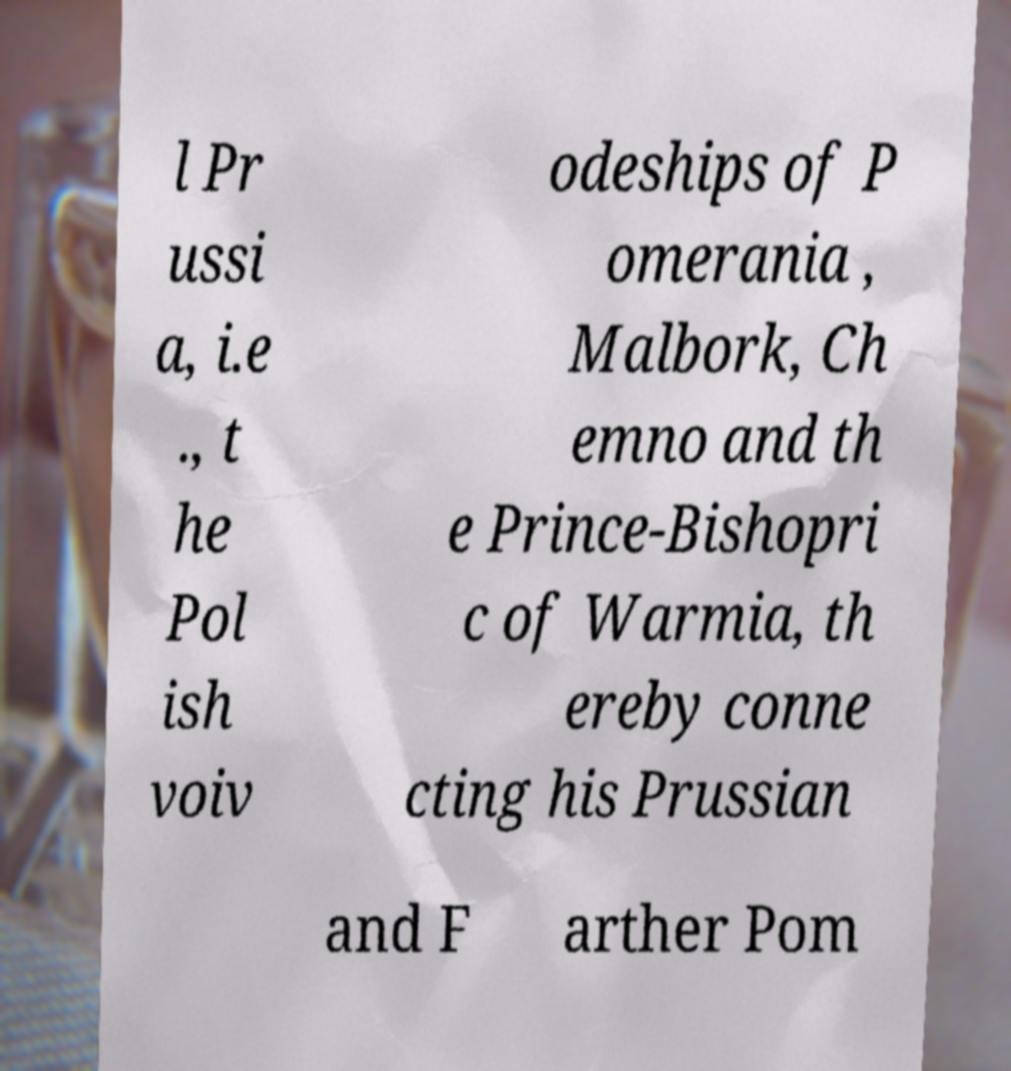There's text embedded in this image that I need extracted. Can you transcribe it verbatim? l Pr ussi a, i.e ., t he Pol ish voiv odeships of P omerania , Malbork, Ch emno and th e Prince-Bishopri c of Warmia, th ereby conne cting his Prussian and F arther Pom 